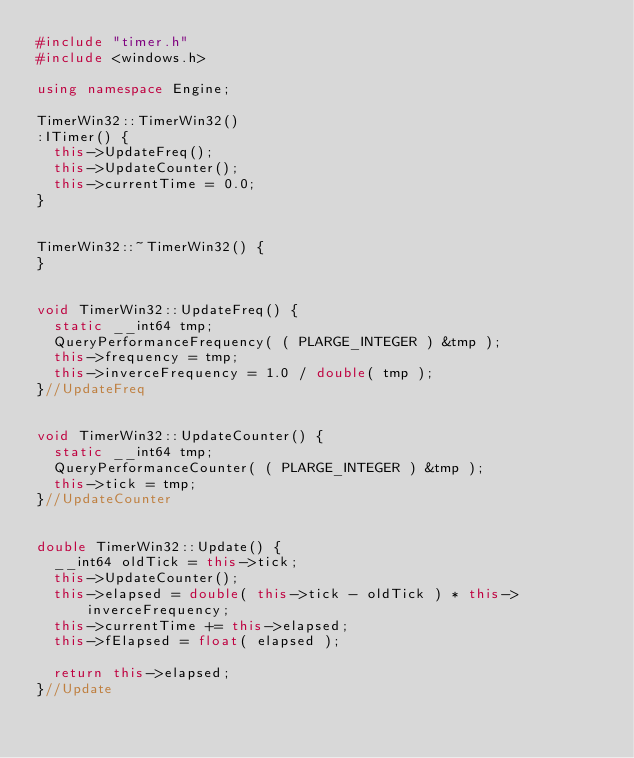Convert code to text. <code><loc_0><loc_0><loc_500><loc_500><_C++_>#include "timer.h"
#include <windows.h>

using namespace Engine;

TimerWin32::TimerWin32()
:ITimer() {
  this->UpdateFreq();
  this->UpdateCounter();
  this->currentTime = 0.0;
}


TimerWin32::~TimerWin32() {
}


void TimerWin32::UpdateFreq() {
  static __int64 tmp;
  QueryPerformanceFrequency( ( PLARGE_INTEGER ) &tmp );
  this->frequency = tmp;
  this->inverceFrequency = 1.0 / double( tmp );
}//UpdateFreq


void TimerWin32::UpdateCounter() {
  static __int64 tmp;
  QueryPerformanceCounter( ( PLARGE_INTEGER ) &tmp );
  this->tick = tmp;
}//UpdateCounter


double TimerWin32::Update() {
  __int64 oldTick = this->tick;
  this->UpdateCounter();
  this->elapsed = double( this->tick - oldTick ) * this->inverceFrequency;
  this->currentTime += this->elapsed;
  this->fElapsed = float( elapsed );

  return this->elapsed;
}//Update
</code> 